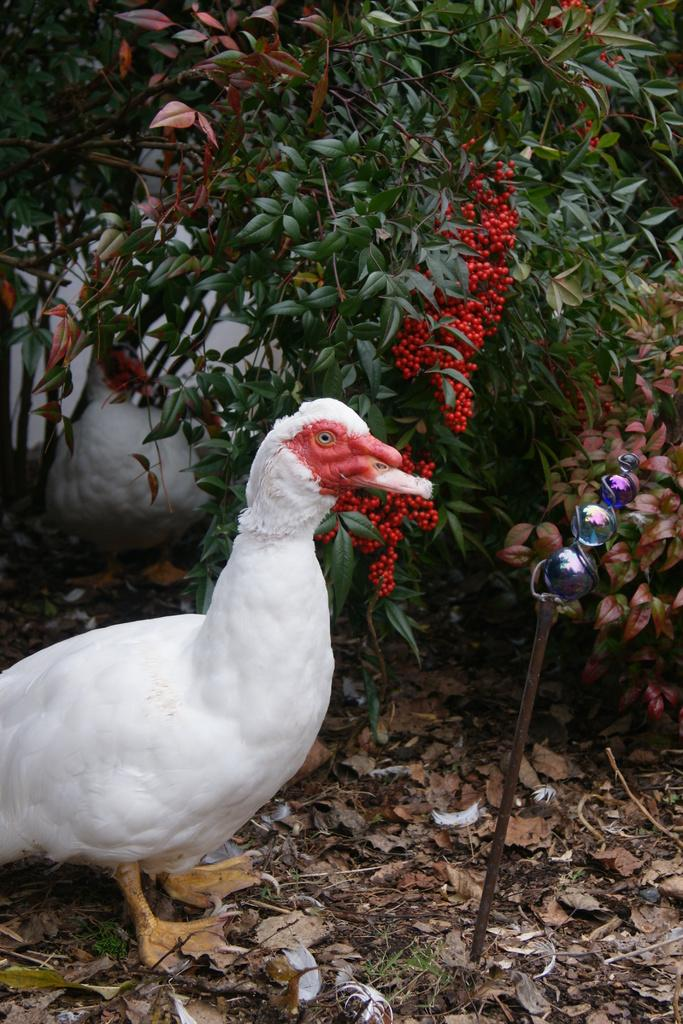What is located on the ground in the image? There is a bird on the ground in the image. What is in front of the person in the image? There is an object in front of a person in the image. What can be seen in the background of the image? There are trees and a wall in the background of the image. How does the bird increase the soda's volume in the image? There is no soda present in the image, and the bird does not interact with any object in a way that would increase its volume. 